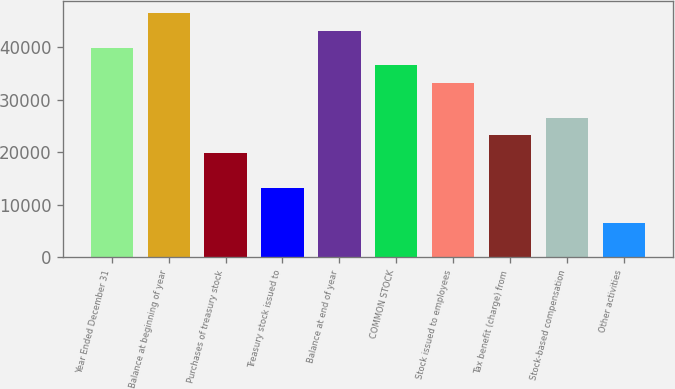Convert chart to OTSL. <chart><loc_0><loc_0><loc_500><loc_500><bar_chart><fcel>Year Ended December 31<fcel>Balance at beginning of year<fcel>Purchases of treasury stock<fcel>Treasury stock issued to<fcel>Balance at end of year<fcel>COMMON STOCK<fcel>Stock issued to employees<fcel>Tax benefit (charge) from<fcel>Stock-based compensation<fcel>Other activities<nl><fcel>39807<fcel>46441<fcel>19905<fcel>13271<fcel>43124<fcel>36490<fcel>33173<fcel>23222<fcel>26539<fcel>6637<nl></chart> 